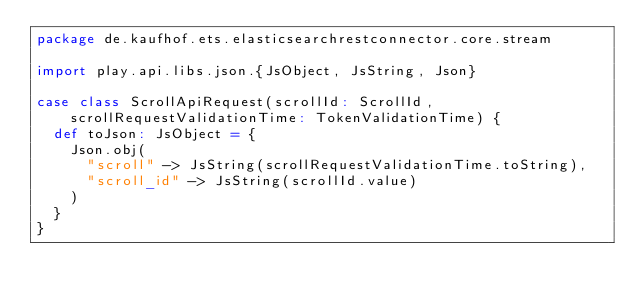<code> <loc_0><loc_0><loc_500><loc_500><_Scala_>package de.kaufhof.ets.elasticsearchrestconnector.core.stream

import play.api.libs.json.{JsObject, JsString, Json}

case class ScrollApiRequest(scrollId: ScrollId, scrollRequestValidationTime: TokenValidationTime) {
  def toJson: JsObject = {
    Json.obj(
      "scroll" -> JsString(scrollRequestValidationTime.toString),
      "scroll_id" -> JsString(scrollId.value)
    )
  }
}
</code> 